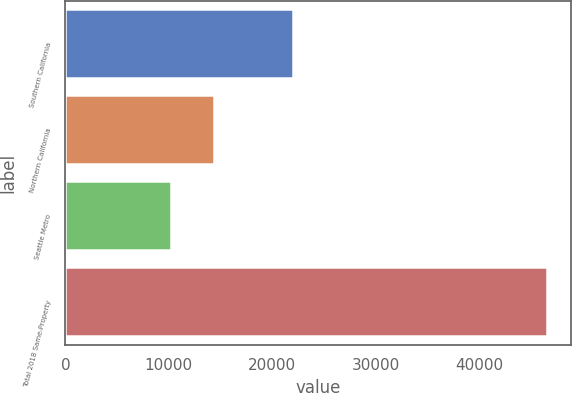Convert chart to OTSL. <chart><loc_0><loc_0><loc_500><loc_500><bar_chart><fcel>Southern California<fcel>Northern California<fcel>Seattle Metro<fcel>Total 2018 Same-Property<nl><fcel>21979<fcel>14356<fcel>10238<fcel>46573<nl></chart> 